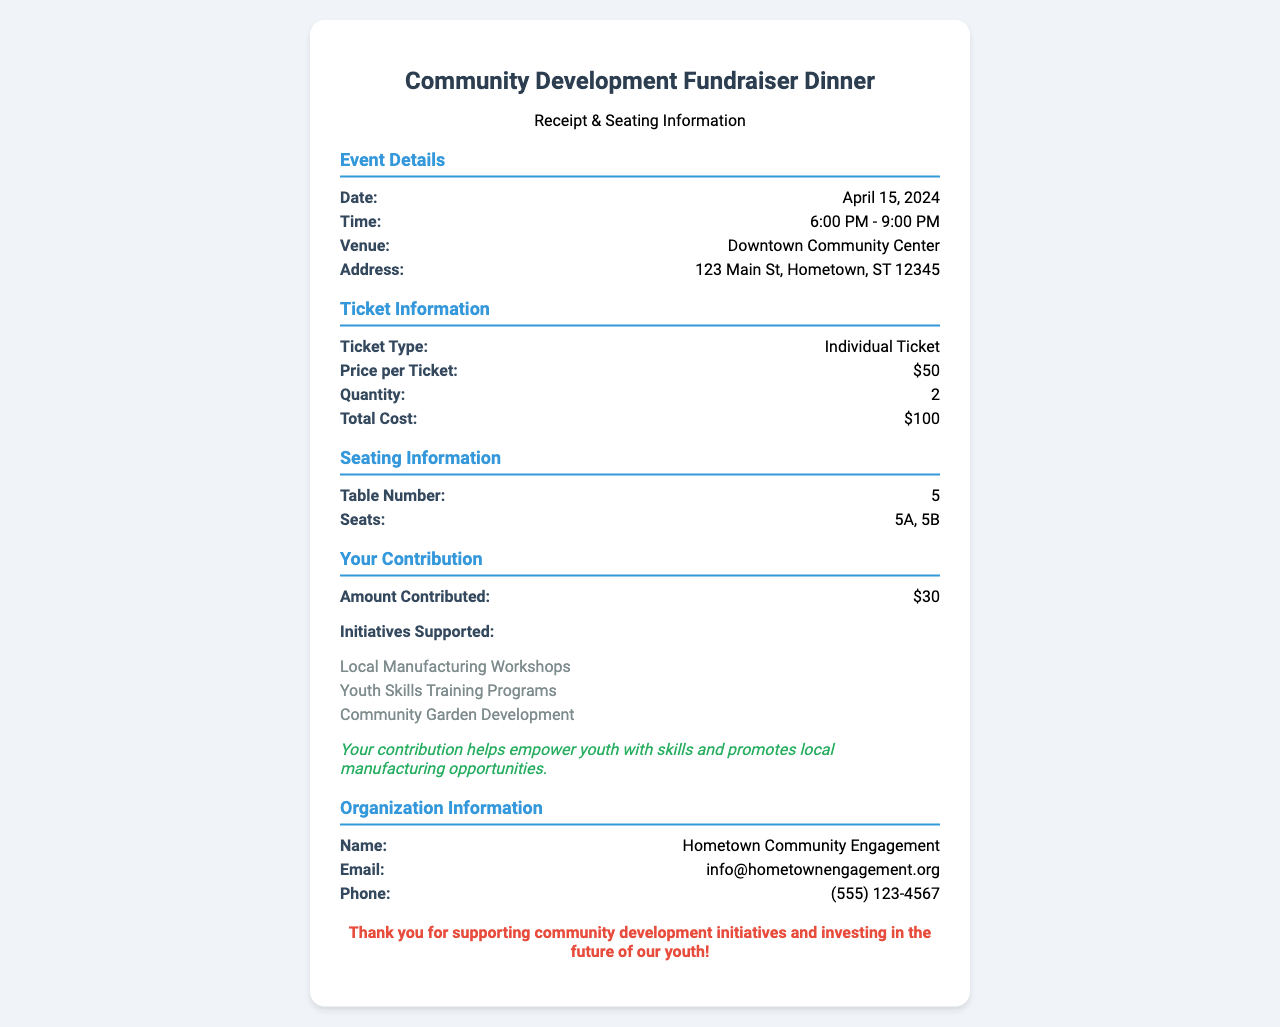What is the event date? The event date is listed in the event details section of the document.
Answer: April 15, 2024 What is the total cost of tickets? The total cost is provided in the ticket details section, which sums the cost for two individual tickets.
Answer: $100 What type of ticket was purchased? The document specifies the type of ticket in the ticket details section.
Answer: Individual Ticket How many seats are reserved? The seating information section indicates the number of seats that are assigned.
Answer: 2 What initiative is included in the contributions? The initiatives supported by the contribution can be found in the contribution details section.
Answer: Local Manufacturing Workshops What is the name of the organization? The organization name is mentioned in the organization details section of the document.
Answer: Hometown Community Engagement What is the seating table number? The table number for seating is provided in the seating information section.
Answer: 5 What is the contribution amount? The contribution amount is detailed in the contribution section of the document.
Answer: $30 What is the impact statement in the contribution details? The impact statement summarizes the purpose of the contribution from the contribution details section.
Answer: Your contribution helps empower youth with skills and promotes local manufacturing opportunities 